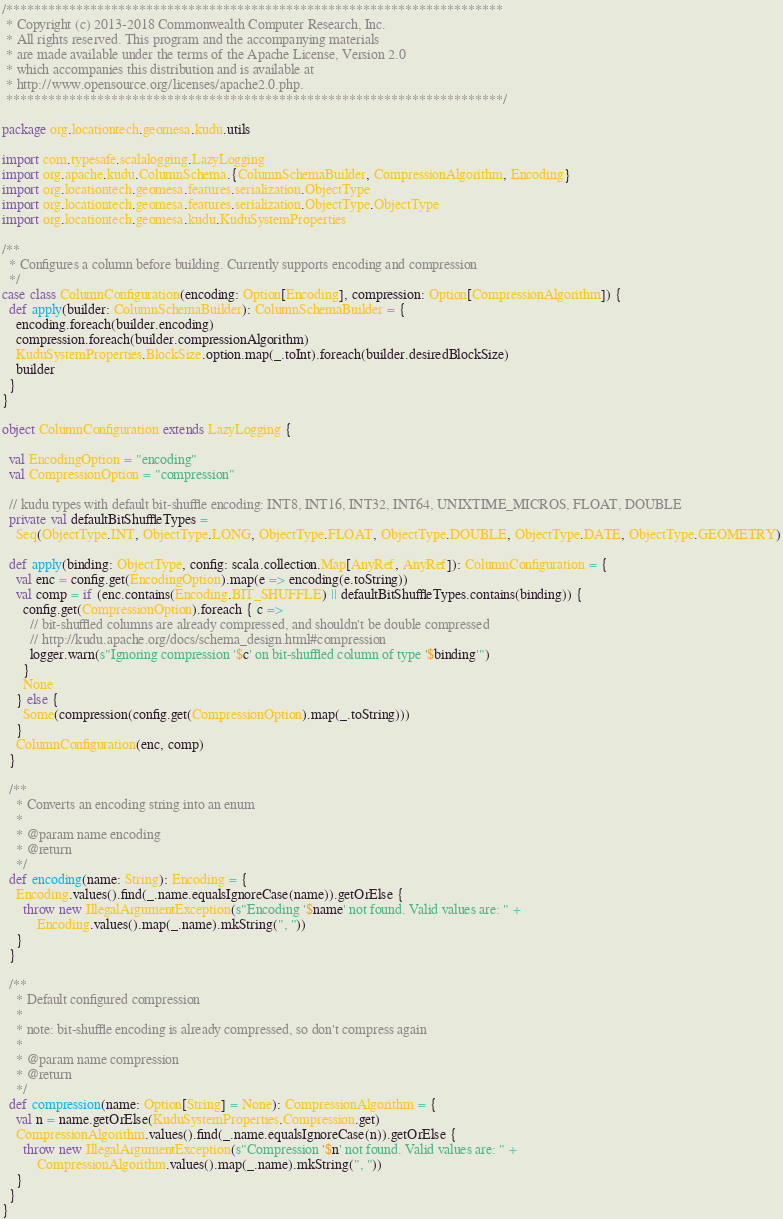<code> <loc_0><loc_0><loc_500><loc_500><_Scala_>/***********************************************************************
 * Copyright (c) 2013-2018 Commonwealth Computer Research, Inc.
 * All rights reserved. This program and the accompanying materials
 * are made available under the terms of the Apache License, Version 2.0
 * which accompanies this distribution and is available at
 * http://www.opensource.org/licenses/apache2.0.php.
 ***********************************************************************/

package org.locationtech.geomesa.kudu.utils

import com.typesafe.scalalogging.LazyLogging
import org.apache.kudu.ColumnSchema.{ColumnSchemaBuilder, CompressionAlgorithm, Encoding}
import org.locationtech.geomesa.features.serialization.ObjectType
import org.locationtech.geomesa.features.serialization.ObjectType.ObjectType
import org.locationtech.geomesa.kudu.KuduSystemProperties

/**
  * Configures a column before building. Currently supports encoding and compression
  */
case class ColumnConfiguration(encoding: Option[Encoding], compression: Option[CompressionAlgorithm]) {
  def apply(builder: ColumnSchemaBuilder): ColumnSchemaBuilder = {
    encoding.foreach(builder.encoding)
    compression.foreach(builder.compressionAlgorithm)
    KuduSystemProperties.BlockSize.option.map(_.toInt).foreach(builder.desiredBlockSize)
    builder
  }
}

object ColumnConfiguration extends LazyLogging {

  val EncodingOption = "encoding"
  val CompressionOption = "compression"

  // kudu types with default bit-shuffle encoding: INT8, INT16, INT32, INT64, UNIXTIME_MICROS, FLOAT, DOUBLE
  private val defaultBitShuffleTypes =
    Seq(ObjectType.INT, ObjectType.LONG, ObjectType.FLOAT, ObjectType.DOUBLE, ObjectType.DATE, ObjectType.GEOMETRY)

  def apply(binding: ObjectType, config: scala.collection.Map[AnyRef, AnyRef]): ColumnConfiguration = {
    val enc = config.get(EncodingOption).map(e => encoding(e.toString))
    val comp = if (enc.contains(Encoding.BIT_SHUFFLE) || defaultBitShuffleTypes.contains(binding)) {
      config.get(CompressionOption).foreach { c =>
        // bit-shuffled columns are already compressed, and shouldn't be double compressed
        // http://kudu.apache.org/docs/schema_design.html#compression
        logger.warn(s"Ignoring compression '$c' on bit-shuffled column of type '$binding'")
      }
      None
    } else {
      Some(compression(config.get(CompressionOption).map(_.toString)))
    }
    ColumnConfiguration(enc, comp)
  }

  /**
    * Converts an encoding string into an enum
    *
    * @param name encoding
    * @return
    */
  def encoding(name: String): Encoding = {
    Encoding.values().find(_.name.equalsIgnoreCase(name)).getOrElse {
      throw new IllegalArgumentException(s"Encoding '$name' not found. Valid values are: " +
          Encoding.values().map(_.name).mkString(", "))
    }
  }

  /**
    * Default configured compression
    *
    * note: bit-shuffle encoding is already compressed, so don't compress again
    *
    * @param name compression
    * @return
    */
  def compression(name: Option[String] = None): CompressionAlgorithm = {
    val n = name.getOrElse(KuduSystemProperties.Compression.get)
    CompressionAlgorithm.values().find(_.name.equalsIgnoreCase(n)).getOrElse {
      throw new IllegalArgumentException(s"Compression '$n' not found. Valid values are: " +
          CompressionAlgorithm.values().map(_.name).mkString(", "))
    }
  }
}
</code> 